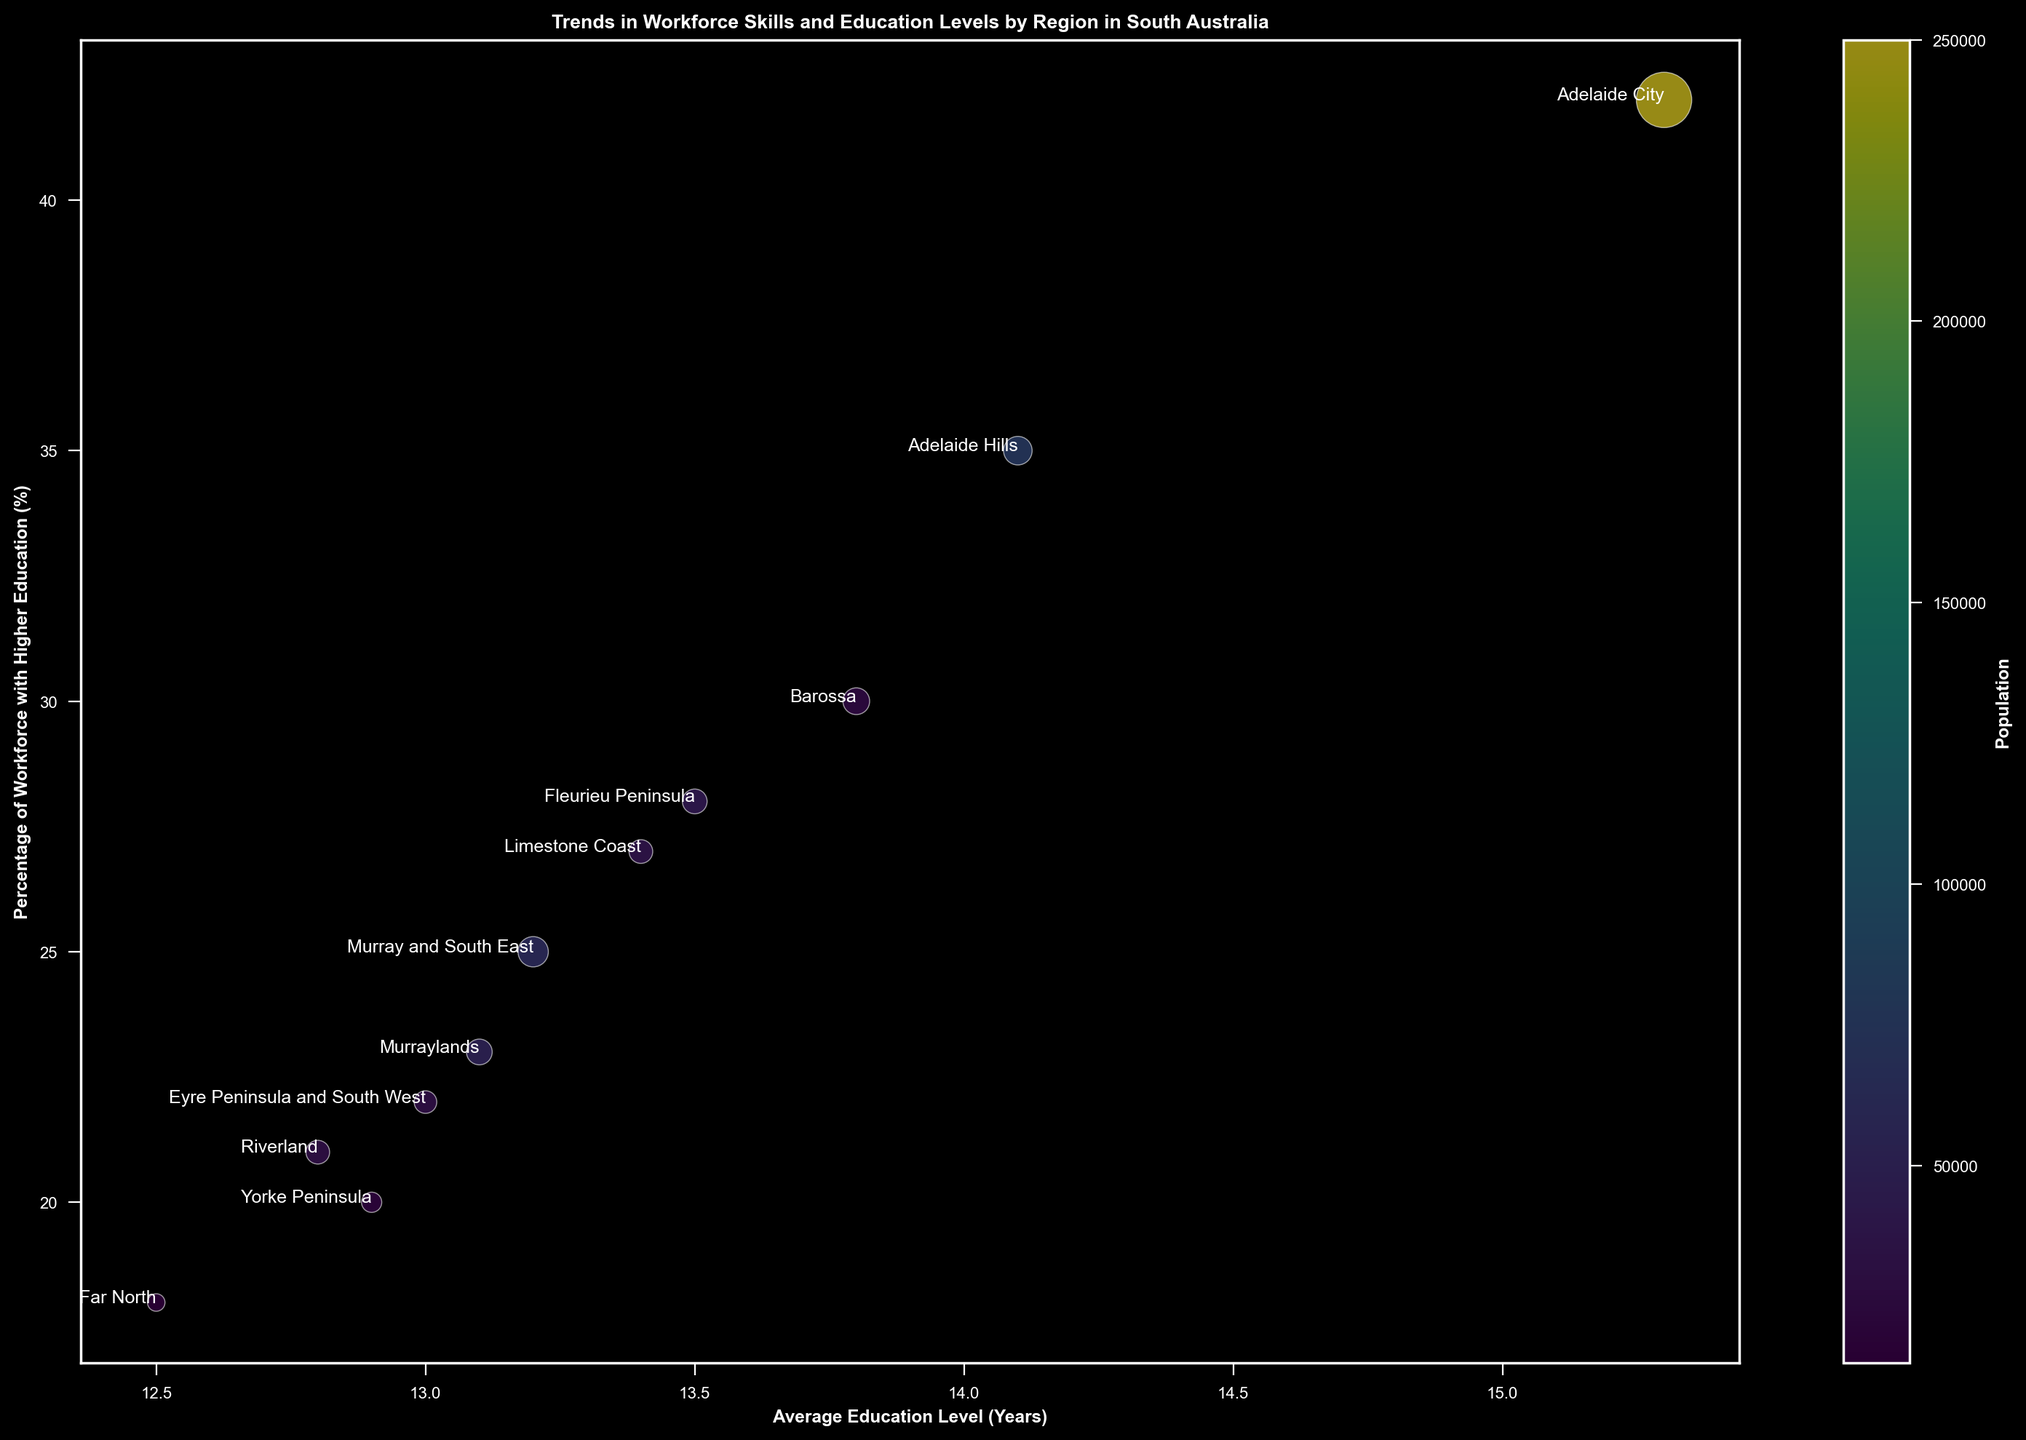What region has the highest average education level in years? To determine this, locate the bubble furthest to the right on the x-axis which represents "Average Education Level (Years)." The region with the highest value on the x-axis has the highest average education level.
Answer: Adelaide City Which region has the highest percentage of workforce with higher education? To find this, look for the bubble that is positioned at the highest point on the y-axis, which represents the "Percentage of Workforce with Higher Education (%)." The highest value on the y-axis indicates the region with the highest percentage of workforce with higher education.
Answer: Adelaide City Which region has the largest population? The color of the bubbles represents the population, with colors closer to yellow indicating a larger population. Identify the most yellow bubble.
Answer: Adelaide City What is the difference in the percentage of the workforce with higher education between Adelaide City and Far North? Locate the bubbles for Adelaide City and Far North on the y-axis. Subtract the percentage of workforce with higher education of Far North from Adelaide City.
Answer: 42% - 18% = 24% Which region has a smaller population, Yorke Peninsula or Riverland? Compare the colors of the bubbles representing Yorke Peninsula and Riverland. The bubble with the greener color indicates a smaller population.
Answer: Yorke Peninsula What is the sum of job openings in Adelaide Hills, Barossa, and Fleurieu Peninsula? Find the "Number of Job Openings" for each region (400 for Adelaide Hills, 350 for Barossa, and 300 for Fleurieu Peninsula). Sum these values.
Answer: 400+350+300 = 1050 Which regions have an average education level greater than 13 years and a percentage of workforce with higher education greater than 30%? Identify the bubbles that lie to the right of 13 on the x-axis and above 30% on the y-axis.
Answer: Adelaide City, Adelaide Hills, Barossa Which region has the smallest number of job openings? The bubble with the smallest size indicates the smallest number of job openings.
Answer: Far North How much higher is the average education level in Adelaide City compared to Yorke Peninsula? Subtract the "Average Education Level (Years)" of Yorke Peninsula from that of Adelaide City.
Answer: 15.3 - 12.9 = 2.4 Considering job openings as well, which region with a higher average education level also has a relatively high number of job openings? Look for regions with bubbles to the right on the x-axis (indicating higher education level) and of larger size (indicating more job openings).
Answer: Adelaide City 